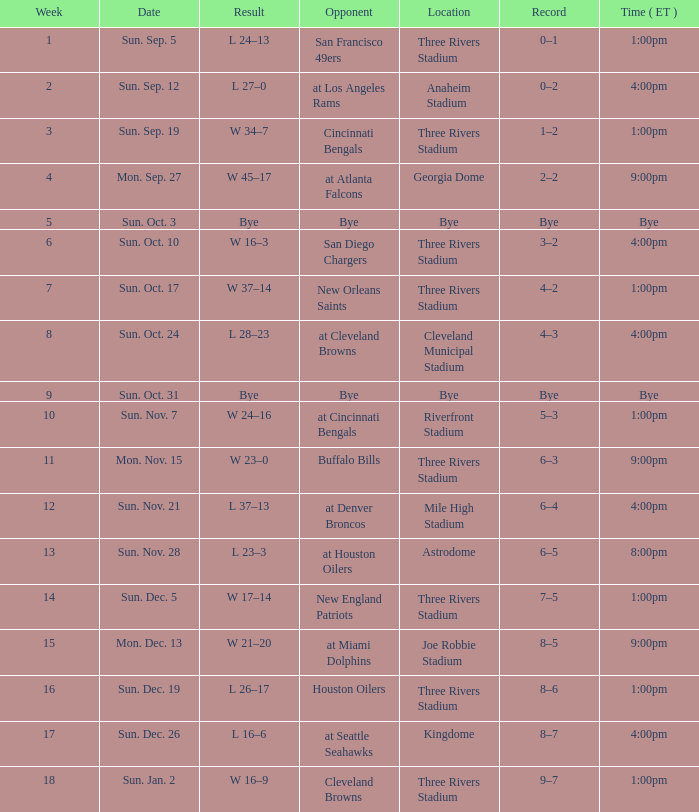What is the result of the game at three rivers stadium with a Record of 6–3? W 23–0. 